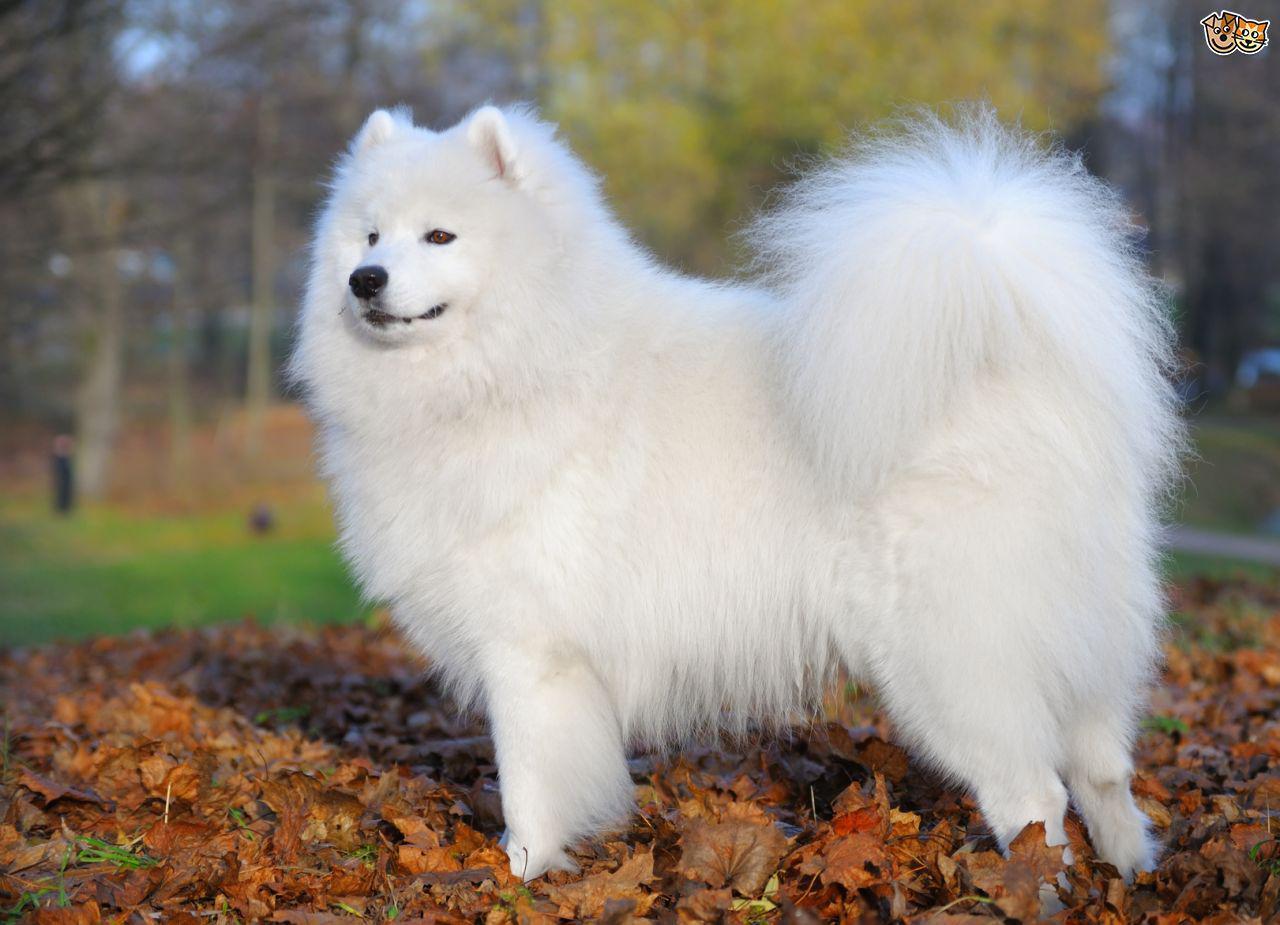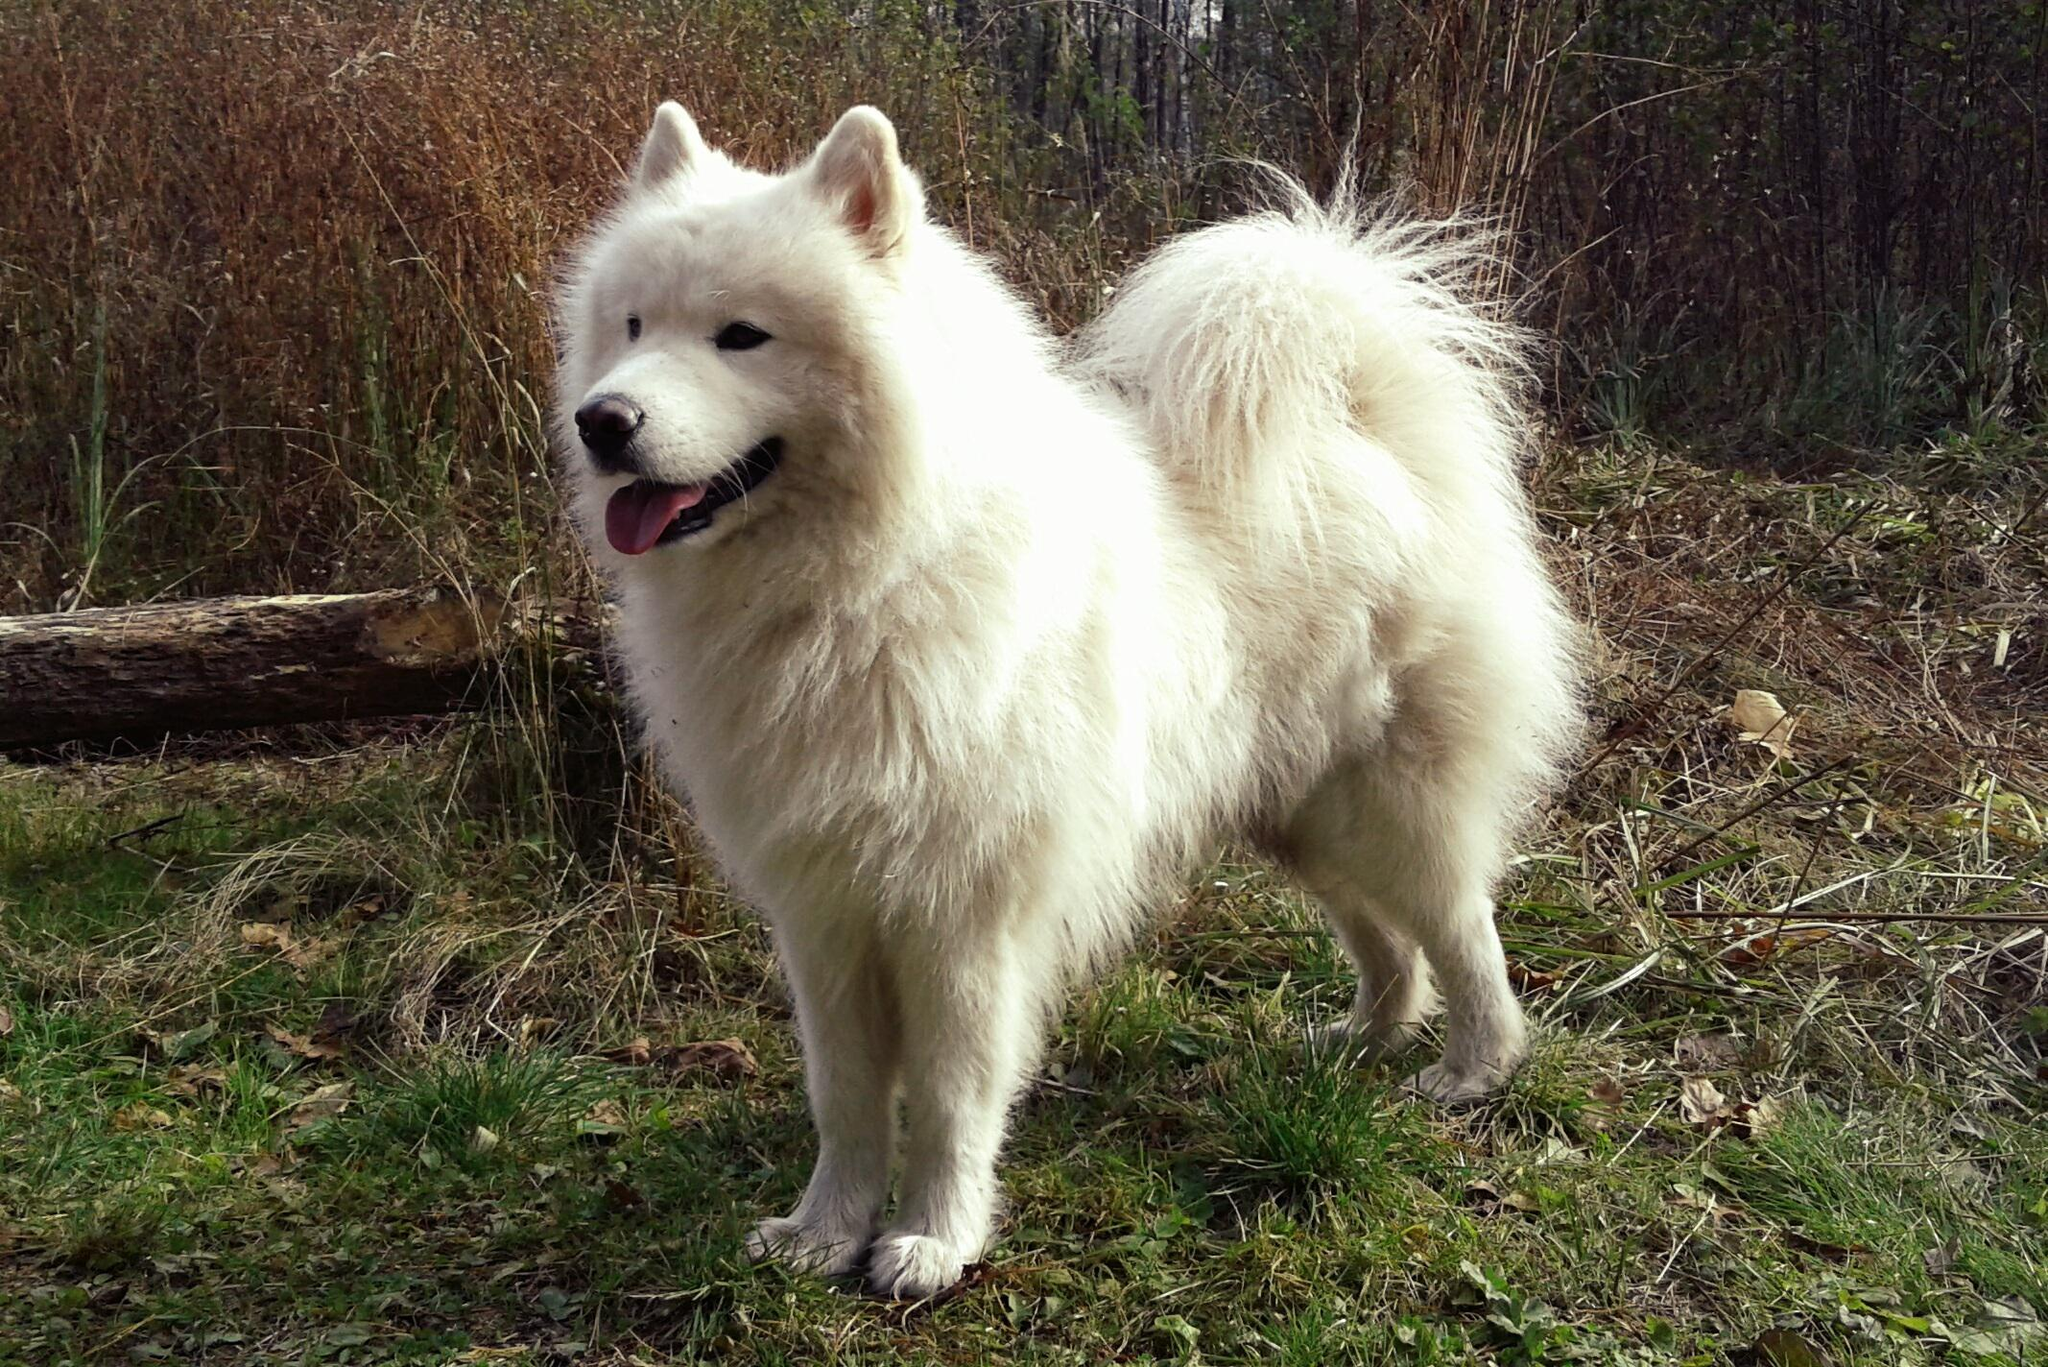The first image is the image on the left, the second image is the image on the right. For the images shown, is this caption "One of the images features a dog eating at a dinner table." true? Answer yes or no. No. The first image is the image on the left, the second image is the image on the right. Examine the images to the left and right. Is the description "Each image contains a single white dog, and at least one image features a dog standing on all fours with its body turned leftward." accurate? Answer yes or no. Yes. 